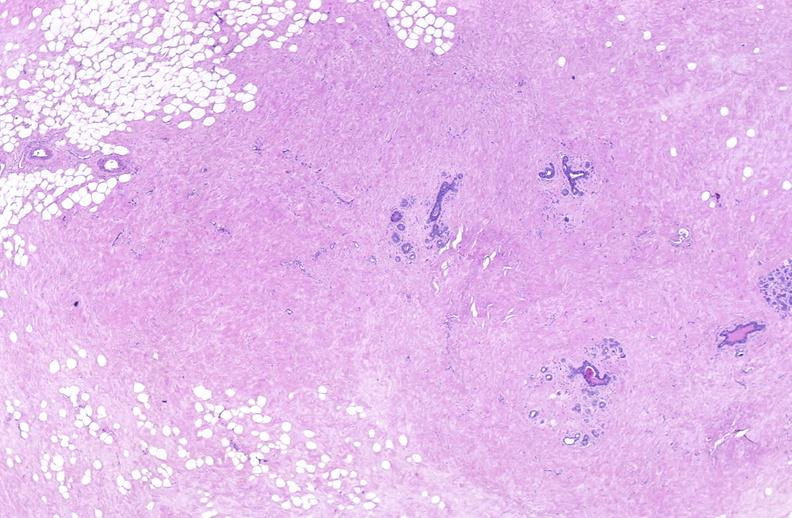does carcinomatosis endometrium primary show breast, fibroadenoma?
Answer the question using a single word or phrase. No 